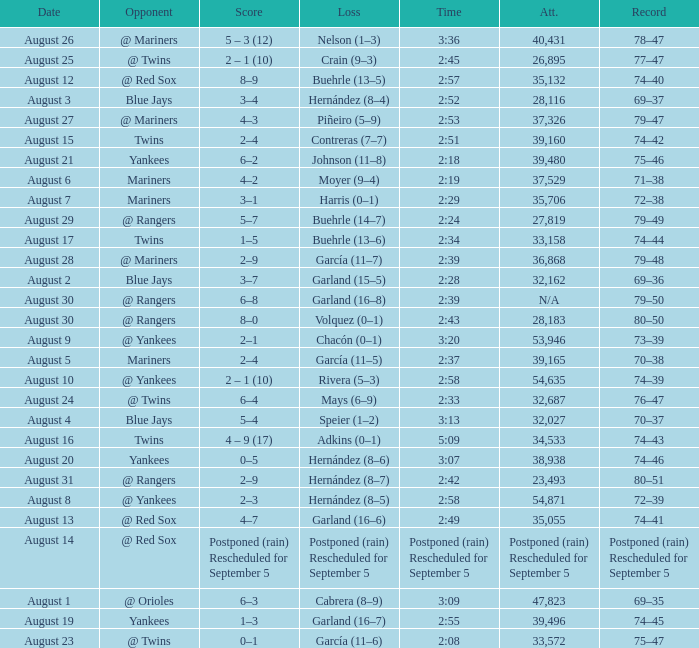Who lost with a time of 2:42? Hernández (8–7). 